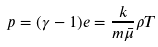<formula> <loc_0><loc_0><loc_500><loc_500>p = ( \gamma - 1 ) e = \frac { k } { m \bar { \mu } } \rho T</formula> 